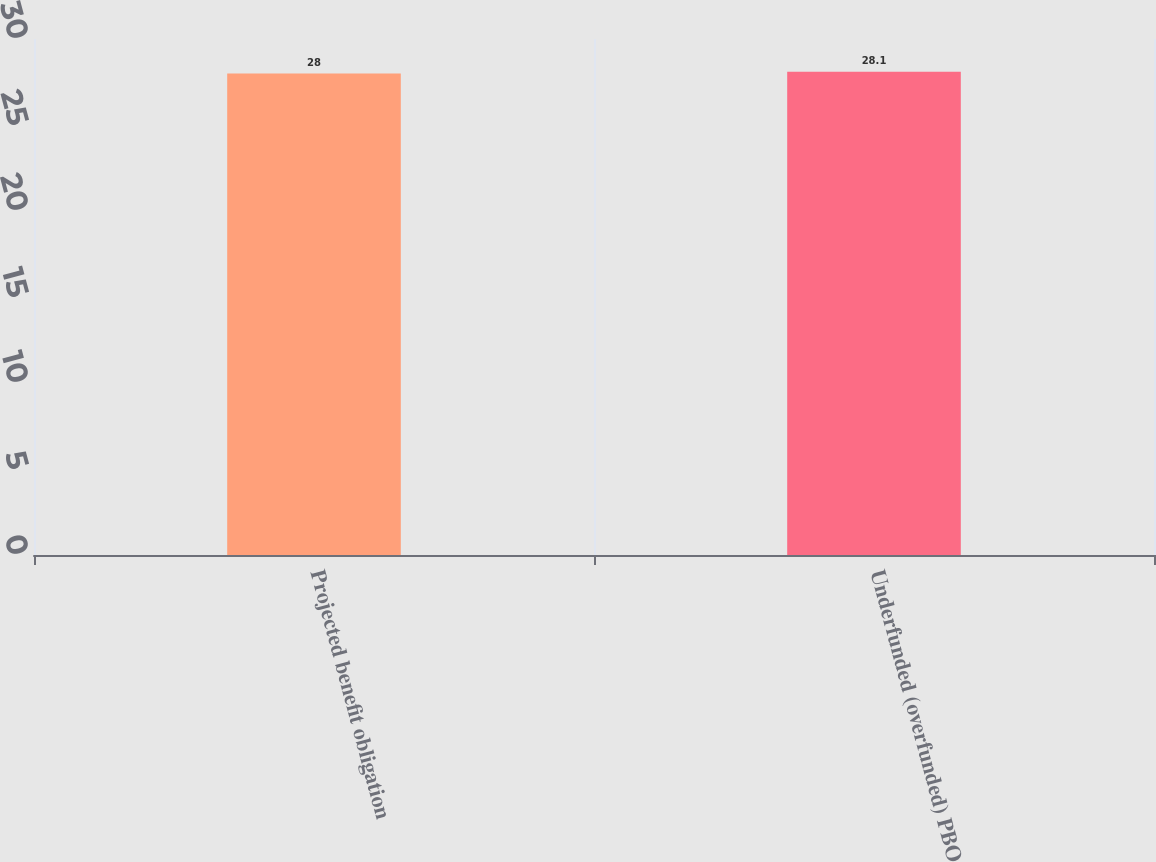Convert chart. <chart><loc_0><loc_0><loc_500><loc_500><bar_chart><fcel>Projected benefit obligation<fcel>Underfunded (overfunded) PBO<nl><fcel>28<fcel>28.1<nl></chart> 